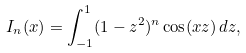<formula> <loc_0><loc_0><loc_500><loc_500>I _ { n } ( x ) = \int _ { - 1 } ^ { 1 } ( 1 - z ^ { 2 } ) ^ { n } \cos ( x z ) \, d z ,</formula> 